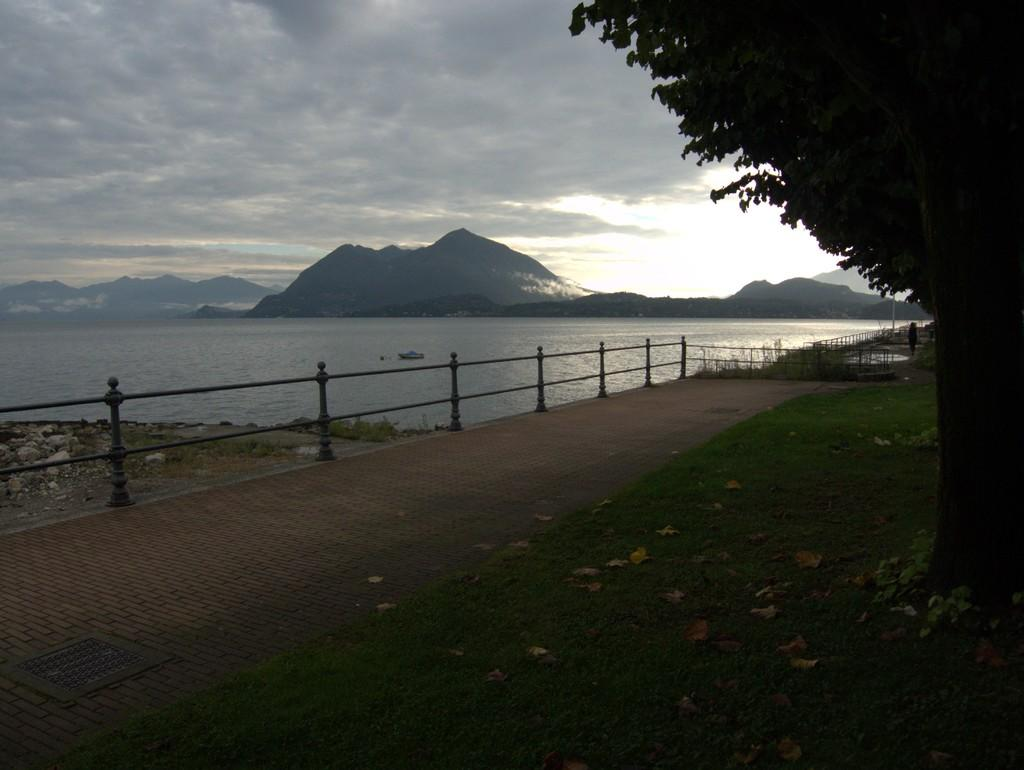What type of vegetation can be seen in the image? There is grass in the image. What type of structure is present in the image? There are iron rods in the image. What other natural elements can be seen in the image? There are trees in the image. What is on the water in the image? There is a boat on the water in the image. What type of landscape feature is visible in the image? There are hills in the image. What is visible in the background of the image? The sky is visible in the background of the image. Where is the stage located in the image? There is no stage present in the image. What color is the tail of the animal in the image? There are no animals with tails present in the image. 